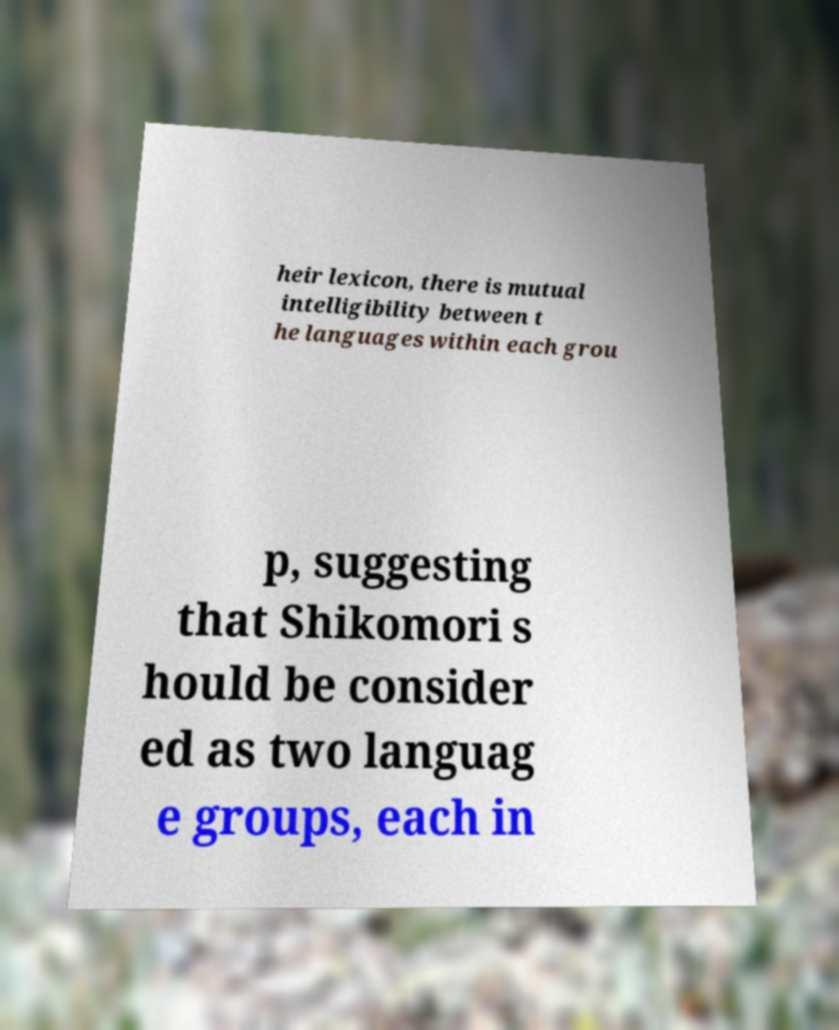There's text embedded in this image that I need extracted. Can you transcribe it verbatim? heir lexicon, there is mutual intelligibility between t he languages within each grou p, suggesting that Shikomori s hould be consider ed as two languag e groups, each in 